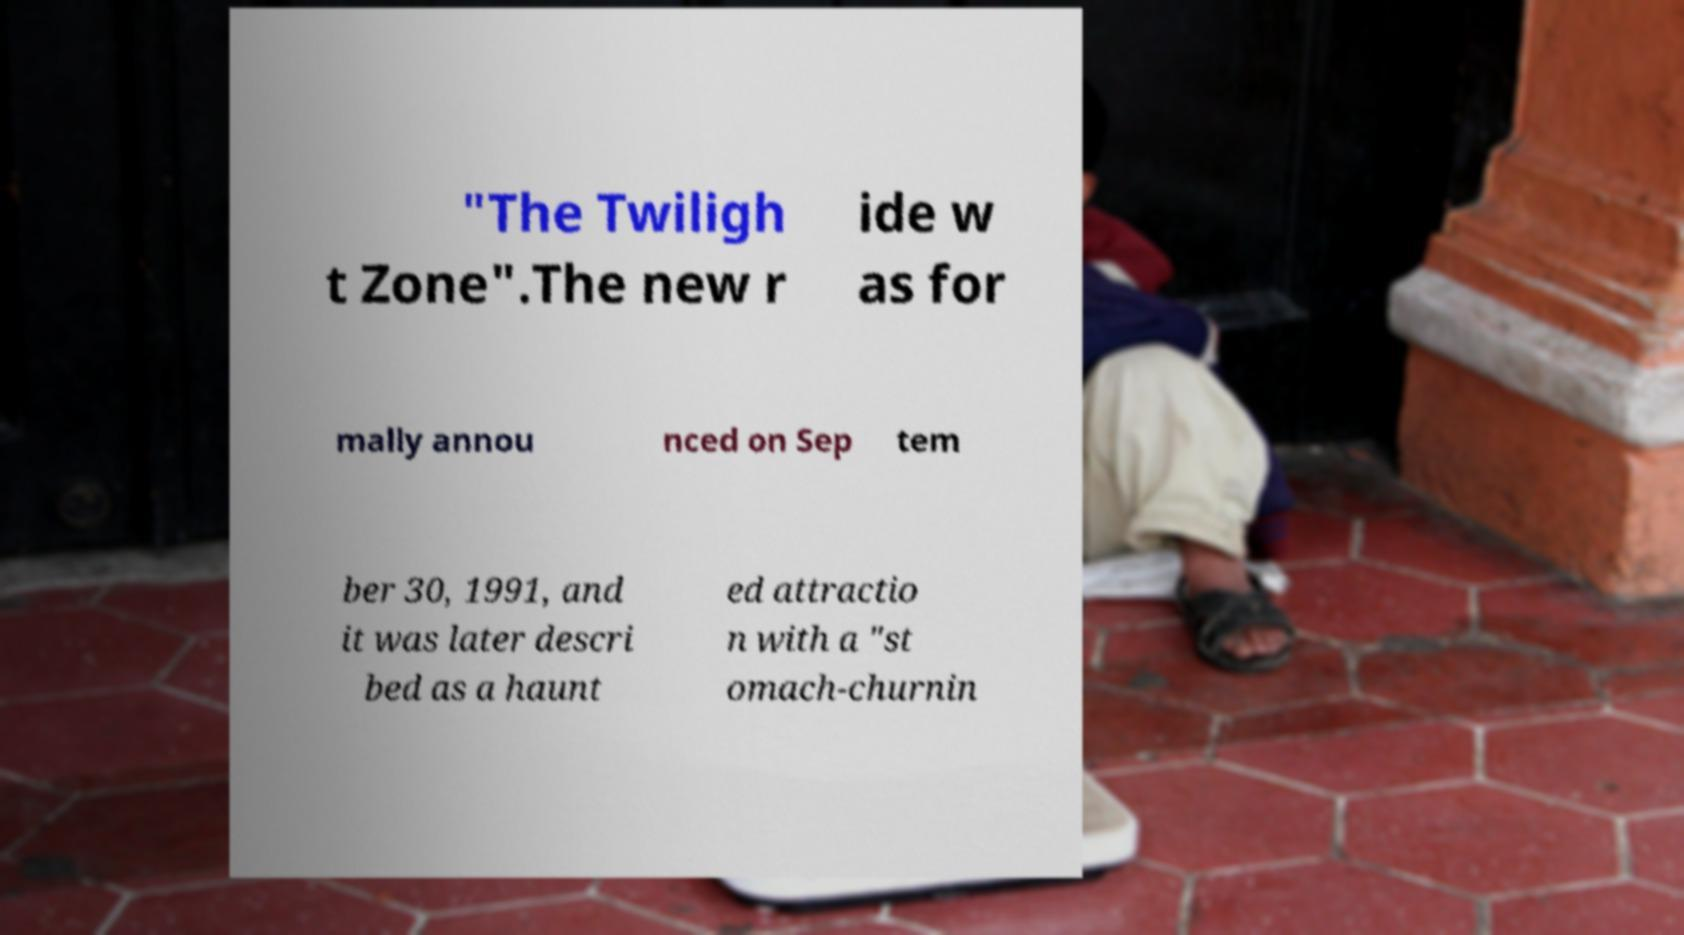Could you assist in decoding the text presented in this image and type it out clearly? "The Twiligh t Zone".The new r ide w as for mally annou nced on Sep tem ber 30, 1991, and it was later descri bed as a haunt ed attractio n with a "st omach-churnin 